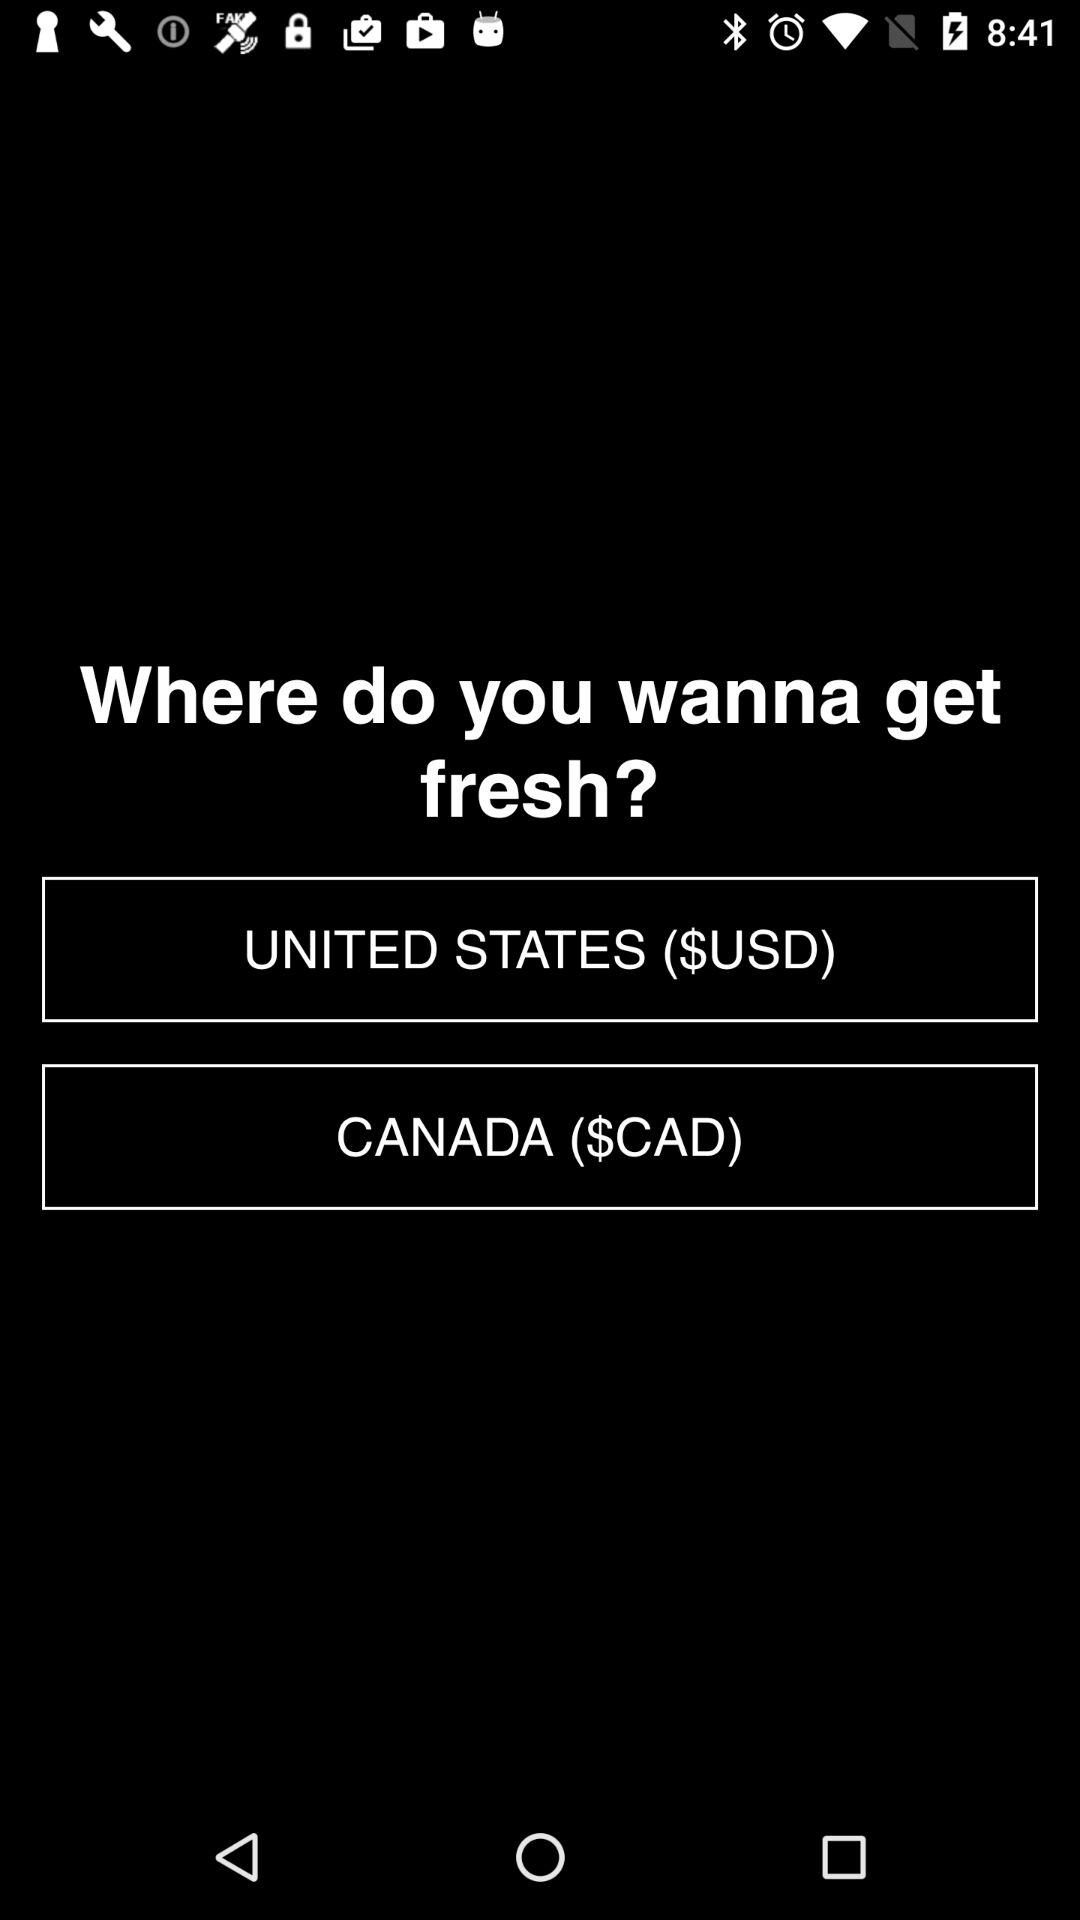What is the currency of the US? The US currency is $USD. 